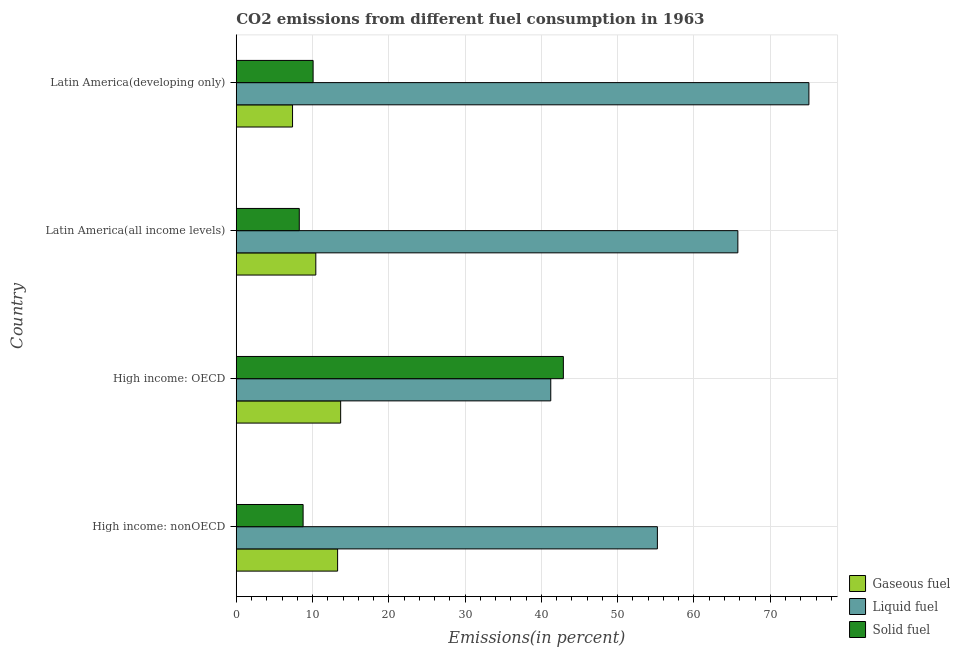Are the number of bars per tick equal to the number of legend labels?
Your answer should be very brief. Yes. Are the number of bars on each tick of the Y-axis equal?
Your answer should be very brief. Yes. How many bars are there on the 3rd tick from the top?
Make the answer very short. 3. How many bars are there on the 4th tick from the bottom?
Keep it short and to the point. 3. What is the label of the 2nd group of bars from the top?
Your answer should be compact. Latin America(all income levels). In how many cases, is the number of bars for a given country not equal to the number of legend labels?
Your response must be concise. 0. What is the percentage of solid fuel emission in Latin America(developing only)?
Ensure brevity in your answer.  10.07. Across all countries, what is the maximum percentage of gaseous fuel emission?
Provide a short and direct response. 13.69. Across all countries, what is the minimum percentage of gaseous fuel emission?
Provide a short and direct response. 7.38. In which country was the percentage of solid fuel emission maximum?
Offer a terse response. High income: OECD. In which country was the percentage of liquid fuel emission minimum?
Offer a terse response. High income: OECD. What is the total percentage of liquid fuel emission in the graph?
Offer a terse response. 237.24. What is the difference between the percentage of liquid fuel emission in High income: OECD and that in High income: nonOECD?
Provide a short and direct response. -13.97. What is the difference between the percentage of liquid fuel emission in High income: OECD and the percentage of gaseous fuel emission in Latin America(developing only)?
Provide a succinct answer. 33.85. What is the average percentage of solid fuel emission per country?
Ensure brevity in your answer.  17.49. What is the difference between the percentage of solid fuel emission and percentage of liquid fuel emission in High income: nonOECD?
Offer a terse response. -46.44. What is the ratio of the percentage of gaseous fuel emission in High income: nonOECD to that in Latin America(all income levels)?
Provide a short and direct response. 1.27. What is the difference between the highest and the second highest percentage of solid fuel emission?
Provide a succinct answer. 32.8. What is the difference between the highest and the lowest percentage of solid fuel emission?
Make the answer very short. 34.61. In how many countries, is the percentage of gaseous fuel emission greater than the average percentage of gaseous fuel emission taken over all countries?
Provide a short and direct response. 2. What does the 2nd bar from the top in High income: OECD represents?
Offer a very short reply. Liquid fuel. What does the 1st bar from the bottom in High income: OECD represents?
Provide a succinct answer. Gaseous fuel. Is it the case that in every country, the sum of the percentage of gaseous fuel emission and percentage of liquid fuel emission is greater than the percentage of solid fuel emission?
Your response must be concise. Yes. How many bars are there?
Your response must be concise. 12. Are all the bars in the graph horizontal?
Keep it short and to the point. Yes. Does the graph contain any zero values?
Give a very brief answer. No. How many legend labels are there?
Your answer should be compact. 3. What is the title of the graph?
Ensure brevity in your answer.  CO2 emissions from different fuel consumption in 1963. Does "Secondary education" appear as one of the legend labels in the graph?
Provide a short and direct response. No. What is the label or title of the X-axis?
Make the answer very short. Emissions(in percent). What is the label or title of the Y-axis?
Make the answer very short. Country. What is the Emissions(in percent) of Gaseous fuel in High income: nonOECD?
Give a very brief answer. 13.29. What is the Emissions(in percent) of Liquid fuel in High income: nonOECD?
Keep it short and to the point. 55.2. What is the Emissions(in percent) of Solid fuel in High income: nonOECD?
Offer a terse response. 8.76. What is the Emissions(in percent) in Gaseous fuel in High income: OECD?
Keep it short and to the point. 13.69. What is the Emissions(in percent) of Liquid fuel in High income: OECD?
Keep it short and to the point. 41.23. What is the Emissions(in percent) in Solid fuel in High income: OECD?
Give a very brief answer. 42.88. What is the Emissions(in percent) in Gaseous fuel in Latin America(all income levels)?
Provide a succinct answer. 10.43. What is the Emissions(in percent) of Liquid fuel in Latin America(all income levels)?
Provide a succinct answer. 65.75. What is the Emissions(in percent) in Solid fuel in Latin America(all income levels)?
Keep it short and to the point. 8.26. What is the Emissions(in percent) of Gaseous fuel in Latin America(developing only)?
Your answer should be very brief. 7.38. What is the Emissions(in percent) in Liquid fuel in Latin America(developing only)?
Ensure brevity in your answer.  75.06. What is the Emissions(in percent) in Solid fuel in Latin America(developing only)?
Your response must be concise. 10.07. Across all countries, what is the maximum Emissions(in percent) in Gaseous fuel?
Offer a very short reply. 13.69. Across all countries, what is the maximum Emissions(in percent) in Liquid fuel?
Give a very brief answer. 75.06. Across all countries, what is the maximum Emissions(in percent) in Solid fuel?
Ensure brevity in your answer.  42.88. Across all countries, what is the minimum Emissions(in percent) in Gaseous fuel?
Give a very brief answer. 7.38. Across all countries, what is the minimum Emissions(in percent) of Liquid fuel?
Make the answer very short. 41.23. Across all countries, what is the minimum Emissions(in percent) in Solid fuel?
Your answer should be compact. 8.26. What is the total Emissions(in percent) of Gaseous fuel in the graph?
Your answer should be compact. 44.78. What is the total Emissions(in percent) of Liquid fuel in the graph?
Provide a short and direct response. 237.24. What is the total Emissions(in percent) of Solid fuel in the graph?
Your response must be concise. 69.98. What is the difference between the Emissions(in percent) of Gaseous fuel in High income: nonOECD and that in High income: OECD?
Offer a terse response. -0.4. What is the difference between the Emissions(in percent) in Liquid fuel in High income: nonOECD and that in High income: OECD?
Keep it short and to the point. 13.98. What is the difference between the Emissions(in percent) in Solid fuel in High income: nonOECD and that in High income: OECD?
Provide a short and direct response. -34.11. What is the difference between the Emissions(in percent) of Gaseous fuel in High income: nonOECD and that in Latin America(all income levels)?
Offer a terse response. 2.86. What is the difference between the Emissions(in percent) of Liquid fuel in High income: nonOECD and that in Latin America(all income levels)?
Offer a very short reply. -10.55. What is the difference between the Emissions(in percent) of Solid fuel in High income: nonOECD and that in Latin America(all income levels)?
Your answer should be very brief. 0.5. What is the difference between the Emissions(in percent) of Gaseous fuel in High income: nonOECD and that in Latin America(developing only)?
Provide a short and direct response. 5.91. What is the difference between the Emissions(in percent) of Liquid fuel in High income: nonOECD and that in Latin America(developing only)?
Offer a terse response. -19.86. What is the difference between the Emissions(in percent) of Solid fuel in High income: nonOECD and that in Latin America(developing only)?
Offer a very short reply. -1.31. What is the difference between the Emissions(in percent) in Gaseous fuel in High income: OECD and that in Latin America(all income levels)?
Ensure brevity in your answer.  3.26. What is the difference between the Emissions(in percent) of Liquid fuel in High income: OECD and that in Latin America(all income levels)?
Your answer should be very brief. -24.52. What is the difference between the Emissions(in percent) in Solid fuel in High income: OECD and that in Latin America(all income levels)?
Ensure brevity in your answer.  34.61. What is the difference between the Emissions(in percent) of Gaseous fuel in High income: OECD and that in Latin America(developing only)?
Give a very brief answer. 6.31. What is the difference between the Emissions(in percent) of Liquid fuel in High income: OECD and that in Latin America(developing only)?
Your answer should be compact. -33.84. What is the difference between the Emissions(in percent) of Solid fuel in High income: OECD and that in Latin America(developing only)?
Make the answer very short. 32.8. What is the difference between the Emissions(in percent) in Gaseous fuel in Latin America(all income levels) and that in Latin America(developing only)?
Provide a succinct answer. 3.05. What is the difference between the Emissions(in percent) in Liquid fuel in Latin America(all income levels) and that in Latin America(developing only)?
Your response must be concise. -9.31. What is the difference between the Emissions(in percent) in Solid fuel in Latin America(all income levels) and that in Latin America(developing only)?
Ensure brevity in your answer.  -1.81. What is the difference between the Emissions(in percent) in Gaseous fuel in High income: nonOECD and the Emissions(in percent) in Liquid fuel in High income: OECD?
Give a very brief answer. -27.94. What is the difference between the Emissions(in percent) of Gaseous fuel in High income: nonOECD and the Emissions(in percent) of Solid fuel in High income: OECD?
Keep it short and to the point. -29.59. What is the difference between the Emissions(in percent) of Liquid fuel in High income: nonOECD and the Emissions(in percent) of Solid fuel in High income: OECD?
Your answer should be compact. 12.33. What is the difference between the Emissions(in percent) in Gaseous fuel in High income: nonOECD and the Emissions(in percent) in Liquid fuel in Latin America(all income levels)?
Make the answer very short. -52.47. What is the difference between the Emissions(in percent) of Gaseous fuel in High income: nonOECD and the Emissions(in percent) of Solid fuel in Latin America(all income levels)?
Provide a succinct answer. 5.02. What is the difference between the Emissions(in percent) of Liquid fuel in High income: nonOECD and the Emissions(in percent) of Solid fuel in Latin America(all income levels)?
Offer a very short reply. 46.94. What is the difference between the Emissions(in percent) of Gaseous fuel in High income: nonOECD and the Emissions(in percent) of Liquid fuel in Latin America(developing only)?
Offer a terse response. -61.78. What is the difference between the Emissions(in percent) of Gaseous fuel in High income: nonOECD and the Emissions(in percent) of Solid fuel in Latin America(developing only)?
Offer a very short reply. 3.21. What is the difference between the Emissions(in percent) in Liquid fuel in High income: nonOECD and the Emissions(in percent) in Solid fuel in Latin America(developing only)?
Your answer should be very brief. 45.13. What is the difference between the Emissions(in percent) of Gaseous fuel in High income: OECD and the Emissions(in percent) of Liquid fuel in Latin America(all income levels)?
Give a very brief answer. -52.06. What is the difference between the Emissions(in percent) of Gaseous fuel in High income: OECD and the Emissions(in percent) of Solid fuel in Latin America(all income levels)?
Give a very brief answer. 5.42. What is the difference between the Emissions(in percent) of Liquid fuel in High income: OECD and the Emissions(in percent) of Solid fuel in Latin America(all income levels)?
Give a very brief answer. 32.96. What is the difference between the Emissions(in percent) of Gaseous fuel in High income: OECD and the Emissions(in percent) of Liquid fuel in Latin America(developing only)?
Ensure brevity in your answer.  -61.38. What is the difference between the Emissions(in percent) in Gaseous fuel in High income: OECD and the Emissions(in percent) in Solid fuel in Latin America(developing only)?
Your answer should be compact. 3.61. What is the difference between the Emissions(in percent) in Liquid fuel in High income: OECD and the Emissions(in percent) in Solid fuel in Latin America(developing only)?
Give a very brief answer. 31.15. What is the difference between the Emissions(in percent) of Gaseous fuel in Latin America(all income levels) and the Emissions(in percent) of Liquid fuel in Latin America(developing only)?
Give a very brief answer. -64.64. What is the difference between the Emissions(in percent) in Gaseous fuel in Latin America(all income levels) and the Emissions(in percent) in Solid fuel in Latin America(developing only)?
Ensure brevity in your answer.  0.35. What is the difference between the Emissions(in percent) of Liquid fuel in Latin America(all income levels) and the Emissions(in percent) of Solid fuel in Latin America(developing only)?
Offer a very short reply. 55.68. What is the average Emissions(in percent) of Gaseous fuel per country?
Make the answer very short. 11.19. What is the average Emissions(in percent) of Liquid fuel per country?
Your answer should be compact. 59.31. What is the average Emissions(in percent) in Solid fuel per country?
Provide a short and direct response. 17.49. What is the difference between the Emissions(in percent) in Gaseous fuel and Emissions(in percent) in Liquid fuel in High income: nonOECD?
Your response must be concise. -41.92. What is the difference between the Emissions(in percent) of Gaseous fuel and Emissions(in percent) of Solid fuel in High income: nonOECD?
Provide a succinct answer. 4.52. What is the difference between the Emissions(in percent) of Liquid fuel and Emissions(in percent) of Solid fuel in High income: nonOECD?
Keep it short and to the point. 46.44. What is the difference between the Emissions(in percent) in Gaseous fuel and Emissions(in percent) in Liquid fuel in High income: OECD?
Keep it short and to the point. -27.54. What is the difference between the Emissions(in percent) of Gaseous fuel and Emissions(in percent) of Solid fuel in High income: OECD?
Offer a terse response. -29.19. What is the difference between the Emissions(in percent) of Liquid fuel and Emissions(in percent) of Solid fuel in High income: OECD?
Make the answer very short. -1.65. What is the difference between the Emissions(in percent) in Gaseous fuel and Emissions(in percent) in Liquid fuel in Latin America(all income levels)?
Offer a terse response. -55.32. What is the difference between the Emissions(in percent) of Gaseous fuel and Emissions(in percent) of Solid fuel in Latin America(all income levels)?
Your answer should be compact. 2.17. What is the difference between the Emissions(in percent) of Liquid fuel and Emissions(in percent) of Solid fuel in Latin America(all income levels)?
Offer a very short reply. 57.49. What is the difference between the Emissions(in percent) in Gaseous fuel and Emissions(in percent) in Liquid fuel in Latin America(developing only)?
Offer a very short reply. -67.68. What is the difference between the Emissions(in percent) in Gaseous fuel and Emissions(in percent) in Solid fuel in Latin America(developing only)?
Your answer should be very brief. -2.7. What is the difference between the Emissions(in percent) of Liquid fuel and Emissions(in percent) of Solid fuel in Latin America(developing only)?
Keep it short and to the point. 64.99. What is the ratio of the Emissions(in percent) in Gaseous fuel in High income: nonOECD to that in High income: OECD?
Make the answer very short. 0.97. What is the ratio of the Emissions(in percent) in Liquid fuel in High income: nonOECD to that in High income: OECD?
Your answer should be very brief. 1.34. What is the ratio of the Emissions(in percent) in Solid fuel in High income: nonOECD to that in High income: OECD?
Your answer should be compact. 0.2. What is the ratio of the Emissions(in percent) of Gaseous fuel in High income: nonOECD to that in Latin America(all income levels)?
Offer a terse response. 1.27. What is the ratio of the Emissions(in percent) of Liquid fuel in High income: nonOECD to that in Latin America(all income levels)?
Give a very brief answer. 0.84. What is the ratio of the Emissions(in percent) of Solid fuel in High income: nonOECD to that in Latin America(all income levels)?
Offer a very short reply. 1.06. What is the ratio of the Emissions(in percent) of Gaseous fuel in High income: nonOECD to that in Latin America(developing only)?
Make the answer very short. 1.8. What is the ratio of the Emissions(in percent) of Liquid fuel in High income: nonOECD to that in Latin America(developing only)?
Give a very brief answer. 0.74. What is the ratio of the Emissions(in percent) in Solid fuel in High income: nonOECD to that in Latin America(developing only)?
Ensure brevity in your answer.  0.87. What is the ratio of the Emissions(in percent) of Gaseous fuel in High income: OECD to that in Latin America(all income levels)?
Ensure brevity in your answer.  1.31. What is the ratio of the Emissions(in percent) in Liquid fuel in High income: OECD to that in Latin America(all income levels)?
Provide a succinct answer. 0.63. What is the ratio of the Emissions(in percent) in Solid fuel in High income: OECD to that in Latin America(all income levels)?
Keep it short and to the point. 5.19. What is the ratio of the Emissions(in percent) in Gaseous fuel in High income: OECD to that in Latin America(developing only)?
Your answer should be very brief. 1.85. What is the ratio of the Emissions(in percent) of Liquid fuel in High income: OECD to that in Latin America(developing only)?
Make the answer very short. 0.55. What is the ratio of the Emissions(in percent) in Solid fuel in High income: OECD to that in Latin America(developing only)?
Keep it short and to the point. 4.26. What is the ratio of the Emissions(in percent) in Gaseous fuel in Latin America(all income levels) to that in Latin America(developing only)?
Offer a terse response. 1.41. What is the ratio of the Emissions(in percent) of Liquid fuel in Latin America(all income levels) to that in Latin America(developing only)?
Your answer should be compact. 0.88. What is the ratio of the Emissions(in percent) in Solid fuel in Latin America(all income levels) to that in Latin America(developing only)?
Offer a very short reply. 0.82. What is the difference between the highest and the second highest Emissions(in percent) in Gaseous fuel?
Your answer should be compact. 0.4. What is the difference between the highest and the second highest Emissions(in percent) of Liquid fuel?
Provide a succinct answer. 9.31. What is the difference between the highest and the second highest Emissions(in percent) of Solid fuel?
Make the answer very short. 32.8. What is the difference between the highest and the lowest Emissions(in percent) of Gaseous fuel?
Provide a succinct answer. 6.31. What is the difference between the highest and the lowest Emissions(in percent) in Liquid fuel?
Your answer should be compact. 33.84. What is the difference between the highest and the lowest Emissions(in percent) of Solid fuel?
Your response must be concise. 34.61. 